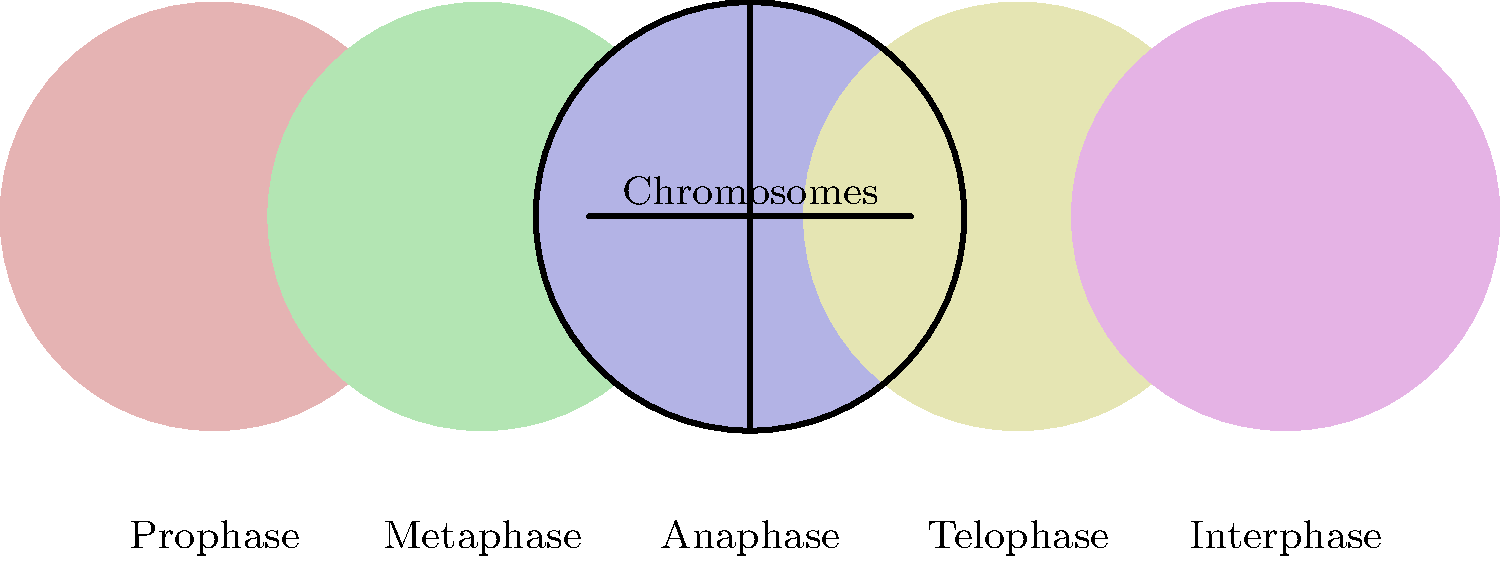In the diagram above, which phase of mitosis is characterized by the alignment of chromosomes along the cell's equatorial plane? To answer this question, let's go through the phases of mitosis step-by-step:

1. Prophase (leftmost circle): Chromosomes condense and become visible. The nuclear envelope breaks down.

2. Metaphase (second from left): Chromosomes align along the cell's equatorial plane (also called the metaphase plate). This is the key characteristic we're looking for in the question.

3. Anaphase (center circle): Sister chromatids separate and move towards opposite poles of the cell.

4. Telophase (second from right): Chromosomes decondense, and the nuclear envelope reforms around each set of chromosomes.

5. Interphase (rightmost circle): This is technically not a phase of mitosis, but rather the period between cell divisions where the cell grows and prepares for the next division.

The question asks about the phase where chromosomes align along the cell's equatorial plane. This alignment is the defining characteristic of metaphase, which is represented by the second circle from the left in the diagram.
Answer: Metaphase 